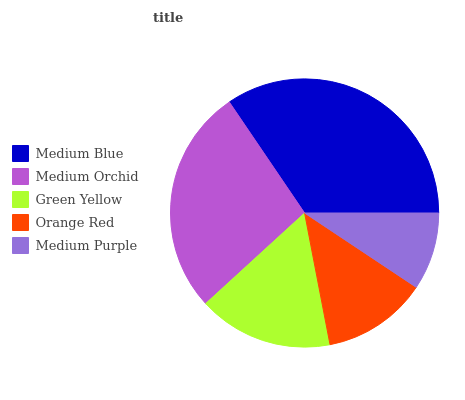Is Medium Purple the minimum?
Answer yes or no. Yes. Is Medium Blue the maximum?
Answer yes or no. Yes. Is Medium Orchid the minimum?
Answer yes or no. No. Is Medium Orchid the maximum?
Answer yes or no. No. Is Medium Blue greater than Medium Orchid?
Answer yes or no. Yes. Is Medium Orchid less than Medium Blue?
Answer yes or no. Yes. Is Medium Orchid greater than Medium Blue?
Answer yes or no. No. Is Medium Blue less than Medium Orchid?
Answer yes or no. No. Is Green Yellow the high median?
Answer yes or no. Yes. Is Green Yellow the low median?
Answer yes or no. Yes. Is Medium Blue the high median?
Answer yes or no. No. Is Medium Blue the low median?
Answer yes or no. No. 